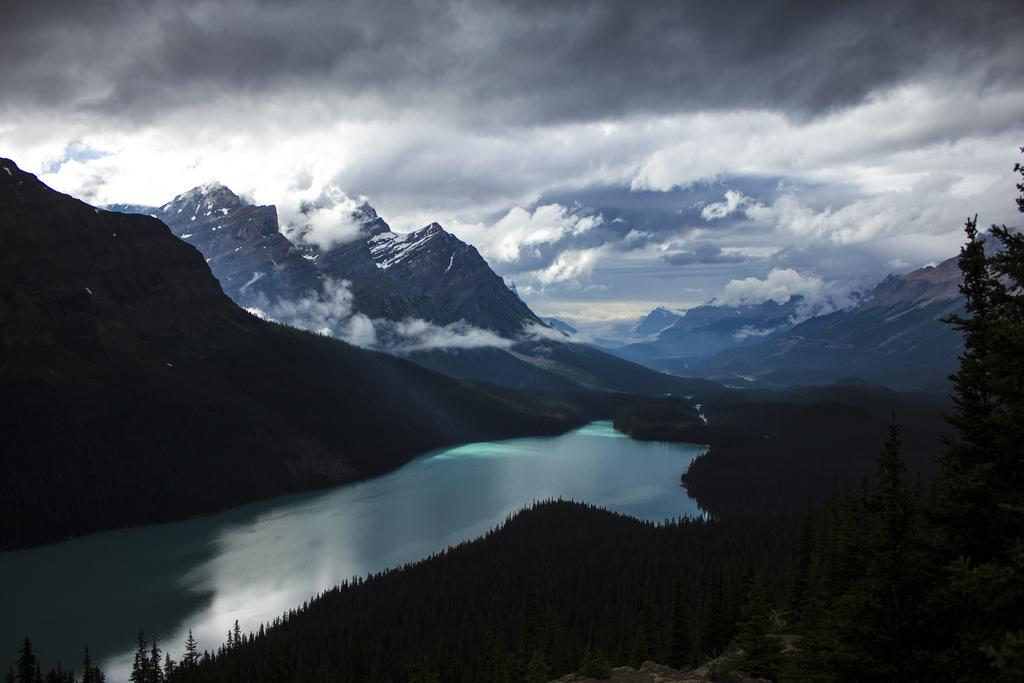What type of vegetation is on the right side of the image? There are plants and trees on the right side of the image. What natural element can be seen in the image besides vegetation? There is water visible in the image. What geographical feature is visible in the background of the image? There are mountains covered with snow in the background of the image. What is the condition of the sky in the image? The sky is cloudy in the image. What type of shoe is visible in the image? There is no shoe present in the image. What type of paint is used to create the border in the image? There is no border or paint present in the image. 